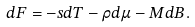<formula> <loc_0><loc_0><loc_500><loc_500>d F = - s d T - \rho d \mu - M d B .</formula> 